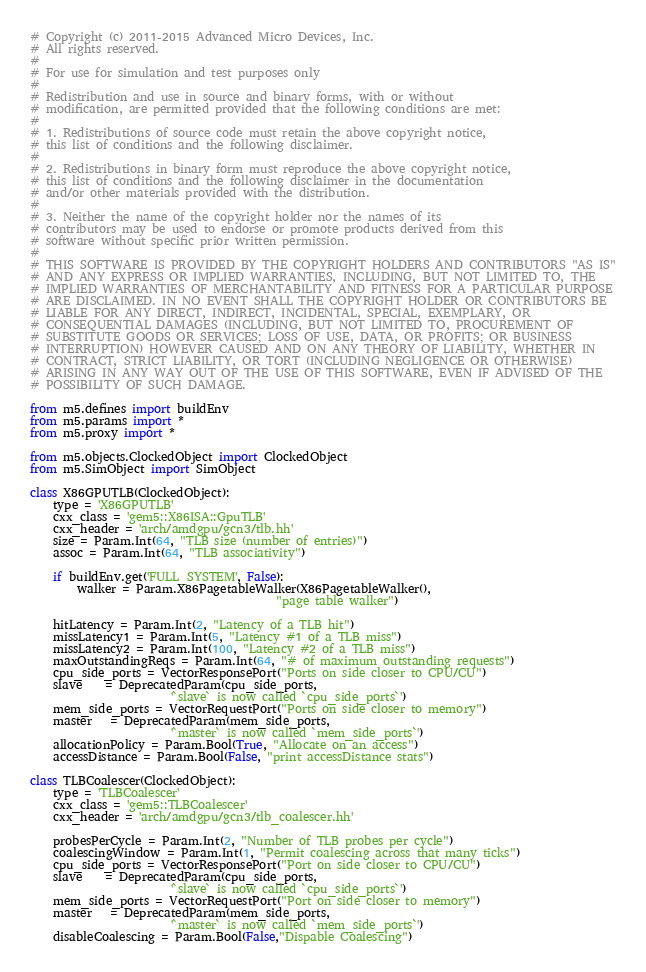Convert code to text. <code><loc_0><loc_0><loc_500><loc_500><_Python_># Copyright (c) 2011-2015 Advanced Micro Devices, Inc.
# All rights reserved.
#
# For use for simulation and test purposes only
#
# Redistribution and use in source and binary forms, with or without
# modification, are permitted provided that the following conditions are met:
#
# 1. Redistributions of source code must retain the above copyright notice,
# this list of conditions and the following disclaimer.
#
# 2. Redistributions in binary form must reproduce the above copyright notice,
# this list of conditions and the following disclaimer in the documentation
# and/or other materials provided with the distribution.
#
# 3. Neither the name of the copyright holder nor the names of its
# contributors may be used to endorse or promote products derived from this
# software without specific prior written permission.
#
# THIS SOFTWARE IS PROVIDED BY THE COPYRIGHT HOLDERS AND CONTRIBUTORS "AS IS"
# AND ANY EXPRESS OR IMPLIED WARRANTIES, INCLUDING, BUT NOT LIMITED TO, THE
# IMPLIED WARRANTIES OF MERCHANTABILITY AND FITNESS FOR A PARTICULAR PURPOSE
# ARE DISCLAIMED. IN NO EVENT SHALL THE COPYRIGHT HOLDER OR CONTRIBUTORS BE
# LIABLE FOR ANY DIRECT, INDIRECT, INCIDENTAL, SPECIAL, EXEMPLARY, OR
# CONSEQUENTIAL DAMAGES (INCLUDING, BUT NOT LIMITED TO, PROCUREMENT OF
# SUBSTITUTE GOODS OR SERVICES; LOSS OF USE, DATA, OR PROFITS; OR BUSINESS
# INTERRUPTION) HOWEVER CAUSED AND ON ANY THEORY OF LIABILITY, WHETHER IN
# CONTRACT, STRICT LIABILITY, OR TORT (INCLUDING NEGLIGENCE OR OTHERWISE)
# ARISING IN ANY WAY OUT OF THE USE OF THIS SOFTWARE, EVEN IF ADVISED OF THE
# POSSIBILITY OF SUCH DAMAGE.

from m5.defines import buildEnv
from m5.params import *
from m5.proxy import *

from m5.objects.ClockedObject import ClockedObject
from m5.SimObject import SimObject

class X86GPUTLB(ClockedObject):
    type = 'X86GPUTLB'
    cxx_class = 'gem5::X86ISA::GpuTLB'
    cxx_header = 'arch/amdgpu/gcn3/tlb.hh'
    size = Param.Int(64, "TLB size (number of entries)")
    assoc = Param.Int(64, "TLB associativity")

    if buildEnv.get('FULL_SYSTEM', False):
        walker = Param.X86PagetableWalker(X86PagetableWalker(),
                                          "page table walker")

    hitLatency = Param.Int(2, "Latency of a TLB hit")
    missLatency1 = Param.Int(5, "Latency #1 of a TLB miss")
    missLatency2 = Param.Int(100, "Latency #2 of a TLB miss")
    maxOutstandingReqs = Param.Int(64, "# of maximum outstanding requests")
    cpu_side_ports = VectorResponsePort("Ports on side closer to CPU/CU")
    slave    = DeprecatedParam(cpu_side_ports,
                        '`slave` is now called `cpu_side_ports`')
    mem_side_ports = VectorRequestPort("Ports on side closer to memory")
    master   = DeprecatedParam(mem_side_ports,
                        '`master` is now called `mem_side_ports`')
    allocationPolicy = Param.Bool(True, "Allocate on an access")
    accessDistance = Param.Bool(False, "print accessDistance stats")

class TLBCoalescer(ClockedObject):
    type = 'TLBCoalescer'
    cxx_class = 'gem5::TLBCoalescer'
    cxx_header = 'arch/amdgpu/gcn3/tlb_coalescer.hh'

    probesPerCycle = Param.Int(2, "Number of TLB probes per cycle")
    coalescingWindow = Param.Int(1, "Permit coalescing across that many ticks")
    cpu_side_ports = VectorResponsePort("Port on side closer to CPU/CU")
    slave    = DeprecatedParam(cpu_side_ports,
                        '`slave` is now called `cpu_side_ports`')
    mem_side_ports = VectorRequestPort("Port on side closer to memory")
    master   = DeprecatedParam(mem_side_ports,
                        '`master` is now called `mem_side_ports`')
    disableCoalescing = Param.Bool(False,"Dispable Coalescing")
</code> 